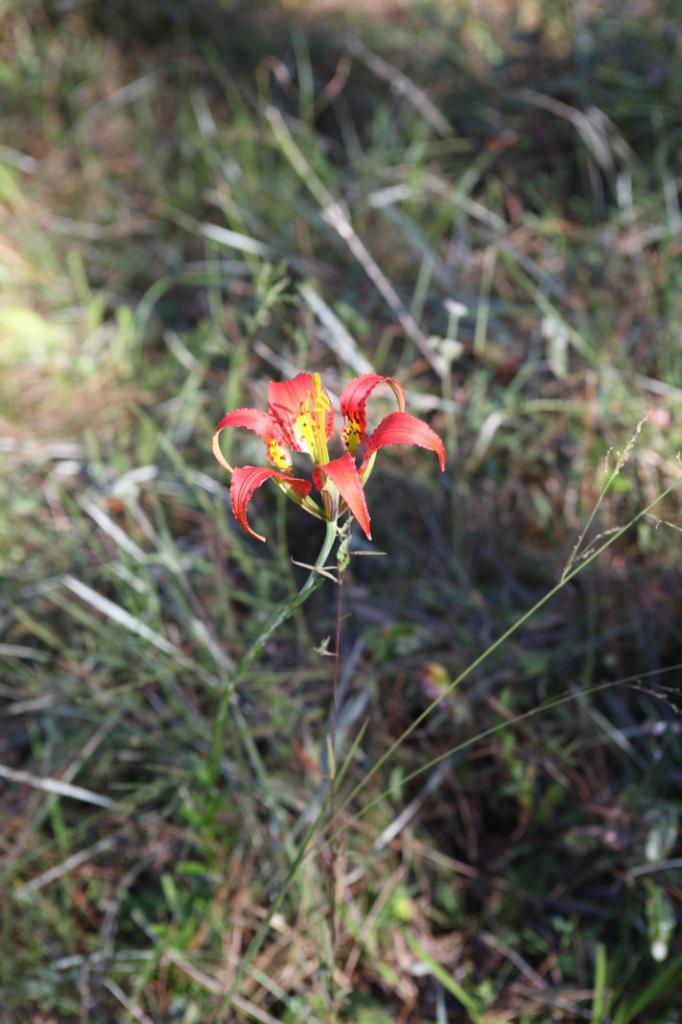How would you summarize this image in a sentence or two? In this picture there is a red color flower on the plant. At the bottom there is grass and there is mud. 